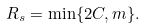Convert formula to latex. <formula><loc_0><loc_0><loc_500><loc_500>R _ { s } = \min \{ 2 C , m \} .</formula> 